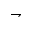Convert formula to latex. <formula><loc_0><loc_0><loc_500><loc_500>\rightharpoondown</formula> 